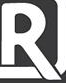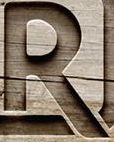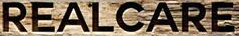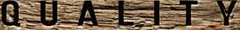What words can you see in these images in sequence, separated by a semicolon? R; R; REALCARE; QUALITY 